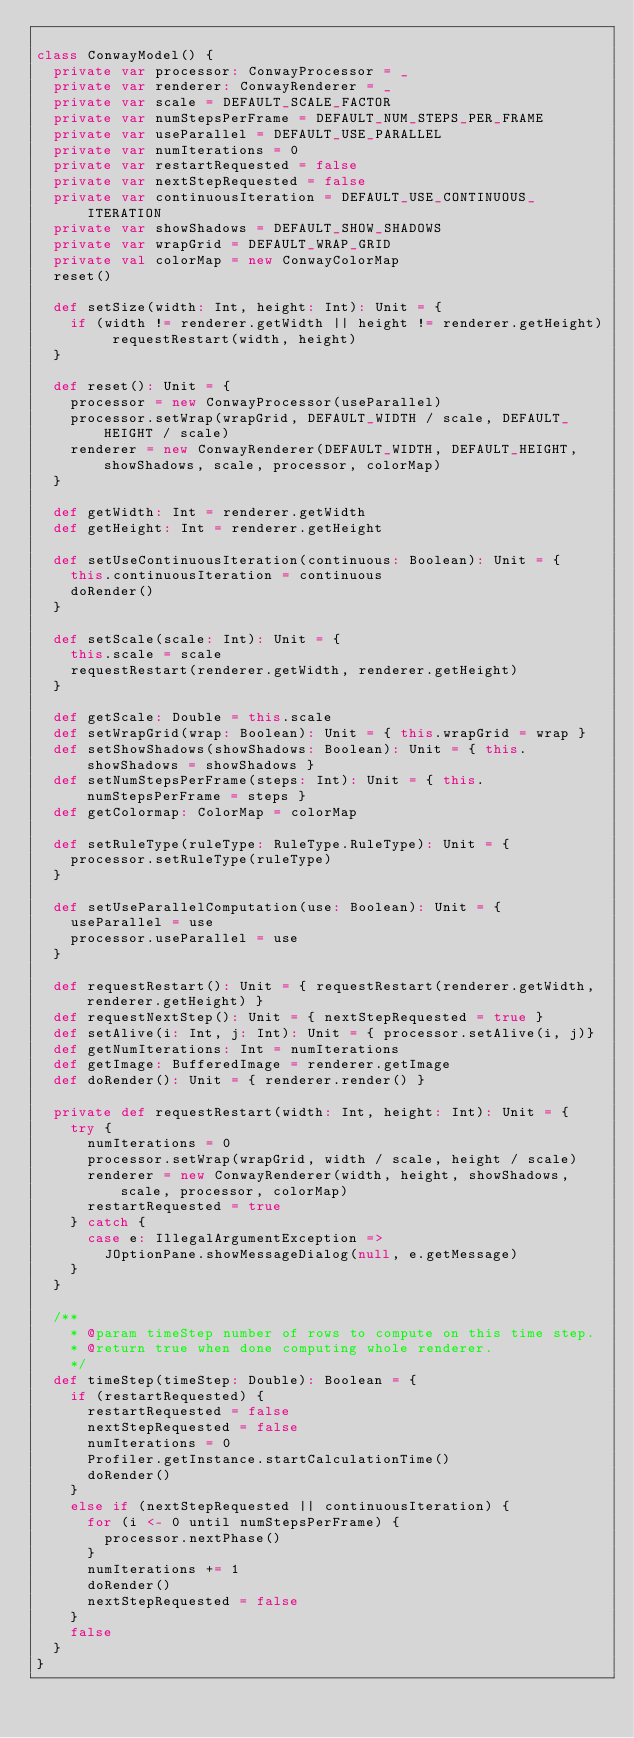Convert code to text. <code><loc_0><loc_0><loc_500><loc_500><_Scala_>
class ConwayModel() {
  private var processor: ConwayProcessor = _
  private var renderer: ConwayRenderer = _
  private var scale = DEFAULT_SCALE_FACTOR
  private var numStepsPerFrame = DEFAULT_NUM_STEPS_PER_FRAME
  private var useParallel = DEFAULT_USE_PARALLEL
  private var numIterations = 0
  private var restartRequested = false
  private var nextStepRequested = false
  private var continuousIteration = DEFAULT_USE_CONTINUOUS_ITERATION
  private var showShadows = DEFAULT_SHOW_SHADOWS
  private var wrapGrid = DEFAULT_WRAP_GRID
  private val colorMap = new ConwayColorMap
  reset()

  def setSize(width: Int, height: Int): Unit = {
    if (width != renderer.getWidth || height != renderer.getHeight) requestRestart(width, height)
  }

  def reset(): Unit = {
    processor = new ConwayProcessor(useParallel)
    processor.setWrap(wrapGrid, DEFAULT_WIDTH / scale, DEFAULT_HEIGHT / scale)
    renderer = new ConwayRenderer(DEFAULT_WIDTH, DEFAULT_HEIGHT, showShadows, scale, processor, colorMap)
  }

  def getWidth: Int = renderer.getWidth
  def getHeight: Int = renderer.getHeight

  def setUseContinuousIteration(continuous: Boolean): Unit = {
    this.continuousIteration = continuous
    doRender()
  }

  def setScale(scale: Int): Unit = {
    this.scale = scale
    requestRestart(renderer.getWidth, renderer.getHeight)
  }

  def getScale: Double = this.scale
  def setWrapGrid(wrap: Boolean): Unit = { this.wrapGrid = wrap }
  def setShowShadows(showShadows: Boolean): Unit = { this.showShadows = showShadows }
  def setNumStepsPerFrame(steps: Int): Unit = { this.numStepsPerFrame = steps }
  def getColormap: ColorMap = colorMap

  def setRuleType(ruleType: RuleType.RuleType): Unit = {
    processor.setRuleType(ruleType)
  }

  def setUseParallelComputation(use: Boolean): Unit = {
    useParallel = use
    processor.useParallel = use
  }

  def requestRestart(): Unit = { requestRestart(renderer.getWidth, renderer.getHeight) }
  def requestNextStep(): Unit = { nextStepRequested = true }
  def setAlive(i: Int, j: Int): Unit = { processor.setAlive(i, j)}
  def getNumIterations: Int = numIterations
  def getImage: BufferedImage = renderer.getImage
  def doRender(): Unit = { renderer.render() }

  private def requestRestart(width: Int, height: Int): Unit = {
    try {
      numIterations = 0
      processor.setWrap(wrapGrid, width / scale, height / scale)
      renderer = new ConwayRenderer(width, height, showShadows, scale, processor, colorMap)
      restartRequested = true
    } catch {
      case e: IllegalArgumentException =>
        JOptionPane.showMessageDialog(null, e.getMessage)
    }
  }

  /**
    * @param timeStep number of rows to compute on this time step.
    * @return true when done computing whole renderer.
    */
  def timeStep(timeStep: Double): Boolean = {
    if (restartRequested) {
      restartRequested = false
      nextStepRequested = false
      numIterations = 0
      Profiler.getInstance.startCalculationTime()
      doRender()
    }
    else if (nextStepRequested || continuousIteration) {
      for (i <- 0 until numStepsPerFrame) {
        processor.nextPhase()
      }
      numIterations += 1
      doRender()
      nextStepRequested = false
    }
    false
  }
}
</code> 